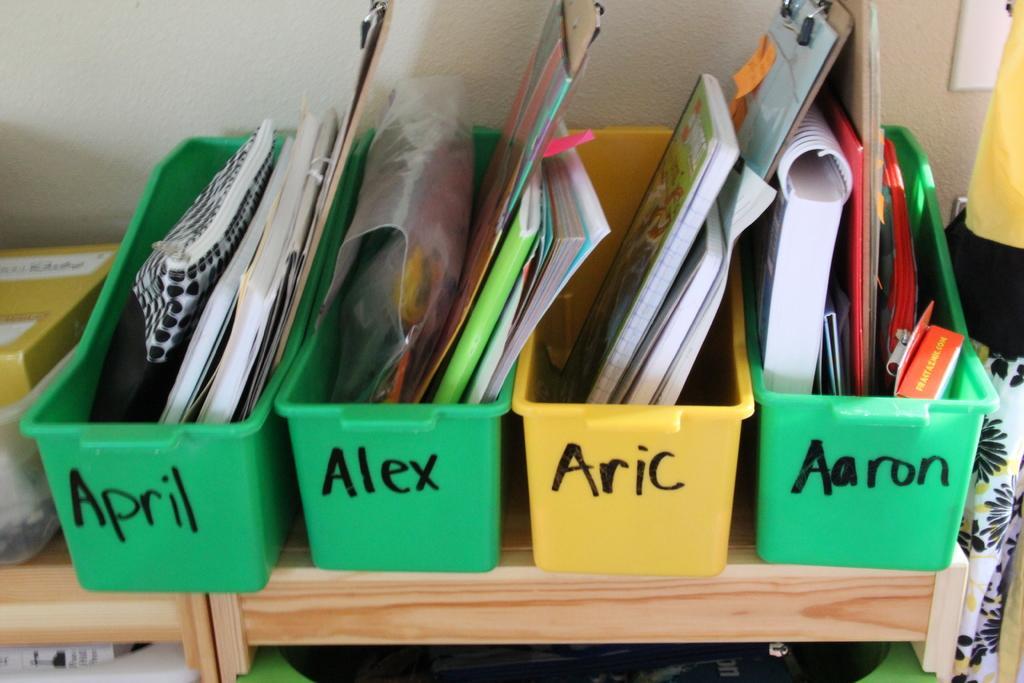How would you summarize this image in a sentence or two? In this image I can see there is a table. On the table there are boxes and there are books and pads in it. And at the side there is a cover and a few objects. And at the back there is a wall. 